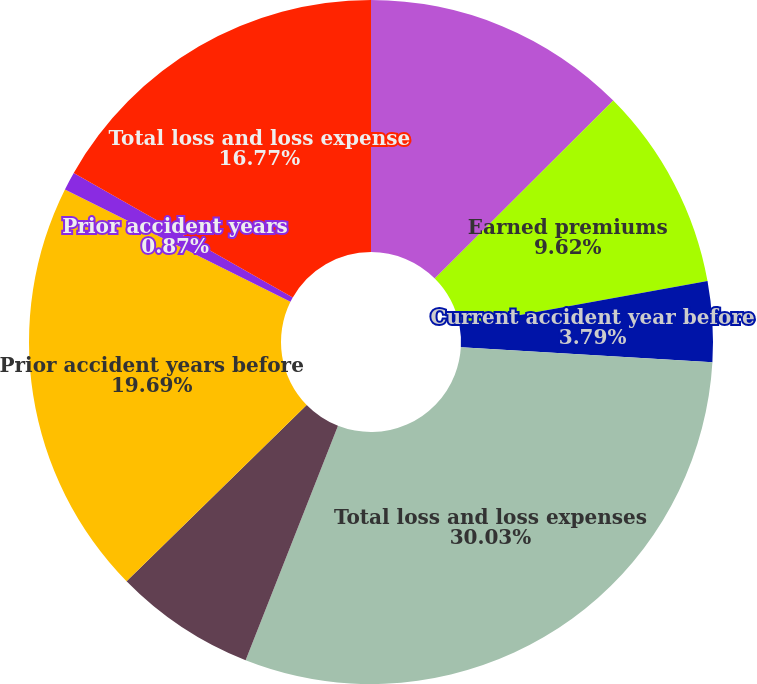Convert chart. <chart><loc_0><loc_0><loc_500><loc_500><pie_chart><fcel>Net written premiums<fcel>Earned premiums<fcel>Current accident year before<fcel>Total loss and loss expenses<fcel>Current accident year<fcel>Prior accident years before<fcel>Prior accident years<fcel>Total loss and loss expense<nl><fcel>12.53%<fcel>9.62%<fcel>3.79%<fcel>30.04%<fcel>6.7%<fcel>19.69%<fcel>0.87%<fcel>16.77%<nl></chart> 